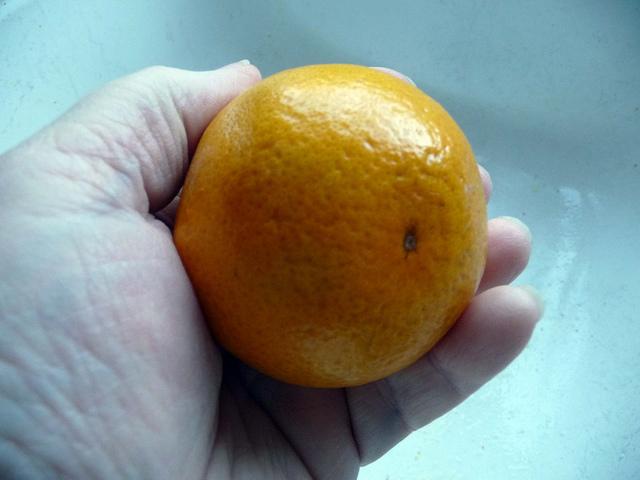Is the fruit held by a man or woman?
Concise answer only. Man. How many fruit are cut?
Concise answer only. 0. Which fruit has dark colored seeds inside?
Short answer required. Orange. Are they offering the fruit to another person?
Be succinct. No. What color is the fruit?
Short answer required. Orange. What type of fruit is this?
Concise answer only. Orange. 